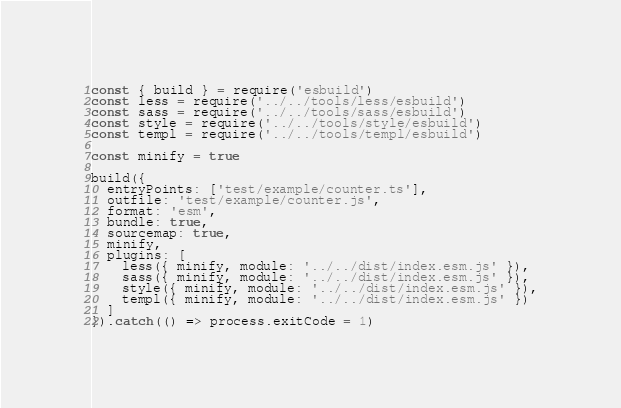Convert code to text. <code><loc_0><loc_0><loc_500><loc_500><_JavaScript_>const { build } = require('esbuild')
const less = require('../../tools/less/esbuild')
const sass = require('../../tools/sass/esbuild')
const style = require('../../tools/style/esbuild')
const templ = require('../../tools/templ/esbuild')

const minify = true

build({
  entryPoints: ['test/example/counter.ts'],
  outfile: 'test/example/counter.js',
  format: 'esm',
  bundle: true,
  sourcemap: true,
  minify,
  plugins: [
    less({ minify, module: '../../dist/index.esm.js' }),
    sass({ minify, module: '../../dist/index.esm.js' }),
    style({ minify, module: '../../dist/index.esm.js' }),
    templ({ minify, module: '../../dist/index.esm.js' })
  ]
}).catch(() => process.exitCode = 1)
</code> 